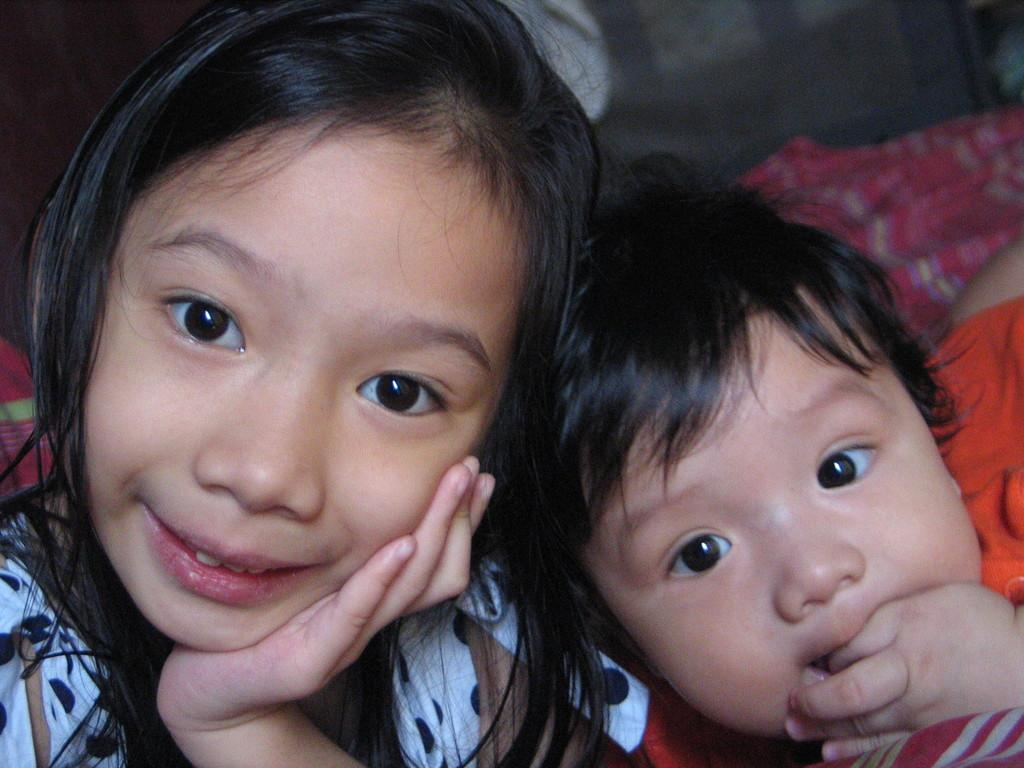How many girls are present in the image? There are two small girls in the image. Where are the girls located in the image? The girls are sitting in the front. What are the girls doing in the image? The girls are posing for the camera. What type of lizards can be seen crawling on the cart in the image? There is no cart or lizards present in the image; it features two small girls sitting and posing for the camera. 